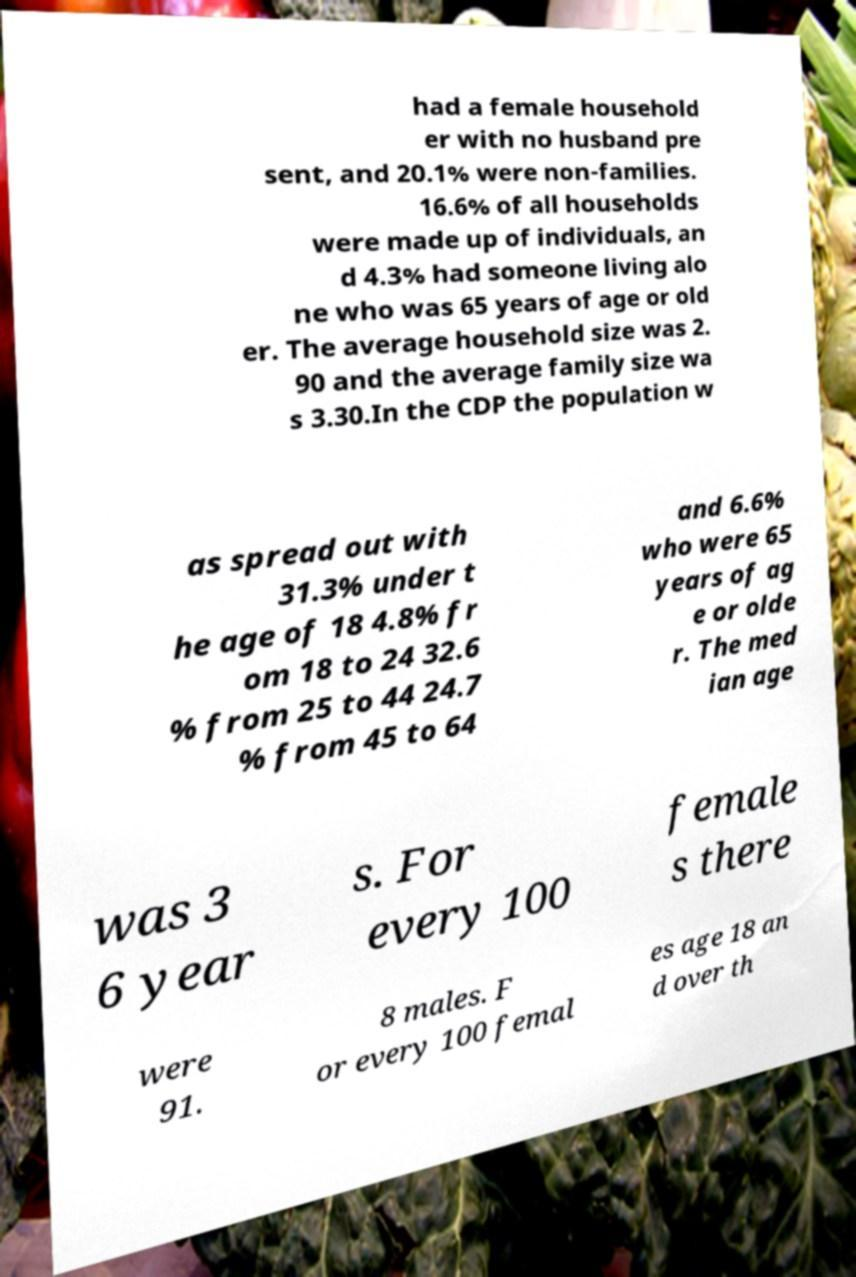Please identify and transcribe the text found in this image. had a female household er with no husband pre sent, and 20.1% were non-families. 16.6% of all households were made up of individuals, an d 4.3% had someone living alo ne who was 65 years of age or old er. The average household size was 2. 90 and the average family size wa s 3.30.In the CDP the population w as spread out with 31.3% under t he age of 18 4.8% fr om 18 to 24 32.6 % from 25 to 44 24.7 % from 45 to 64 and 6.6% who were 65 years of ag e or olde r. The med ian age was 3 6 year s. For every 100 female s there were 91. 8 males. F or every 100 femal es age 18 an d over th 